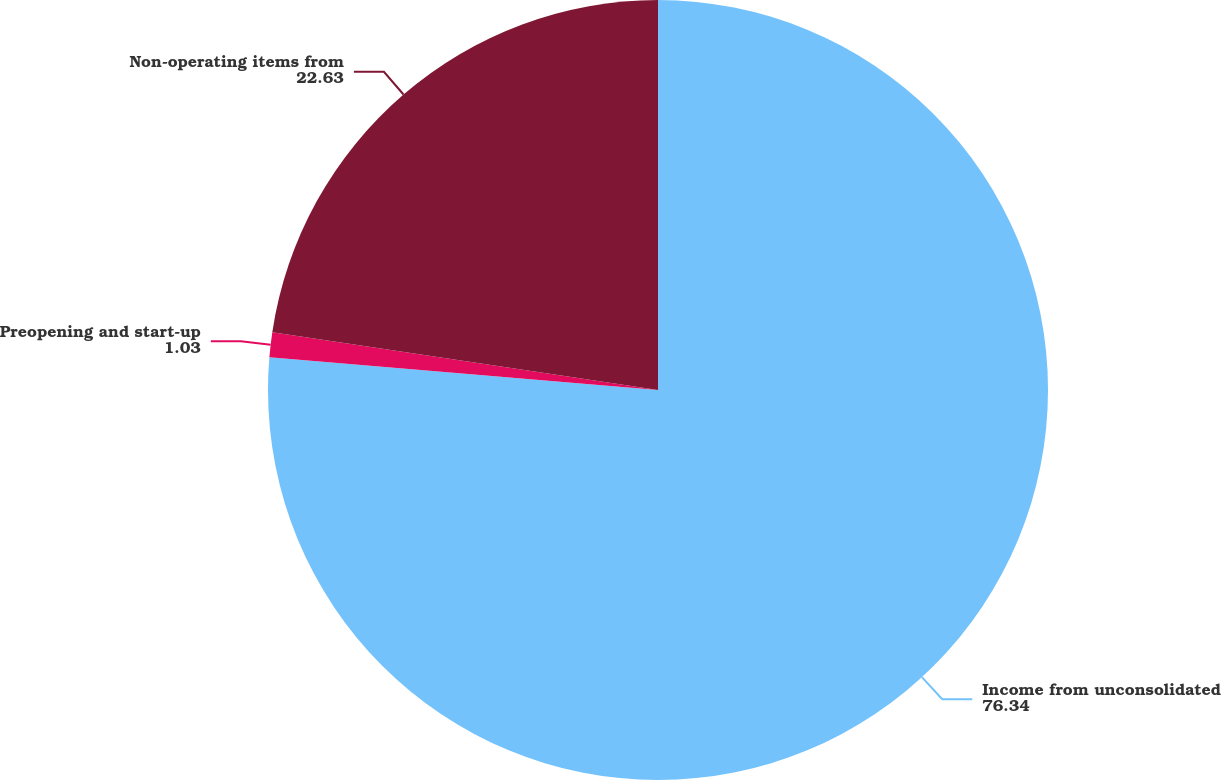Convert chart. <chart><loc_0><loc_0><loc_500><loc_500><pie_chart><fcel>Income from unconsolidated<fcel>Preopening and start-up<fcel>Non-operating items from<nl><fcel>76.34%<fcel>1.03%<fcel>22.63%<nl></chart> 